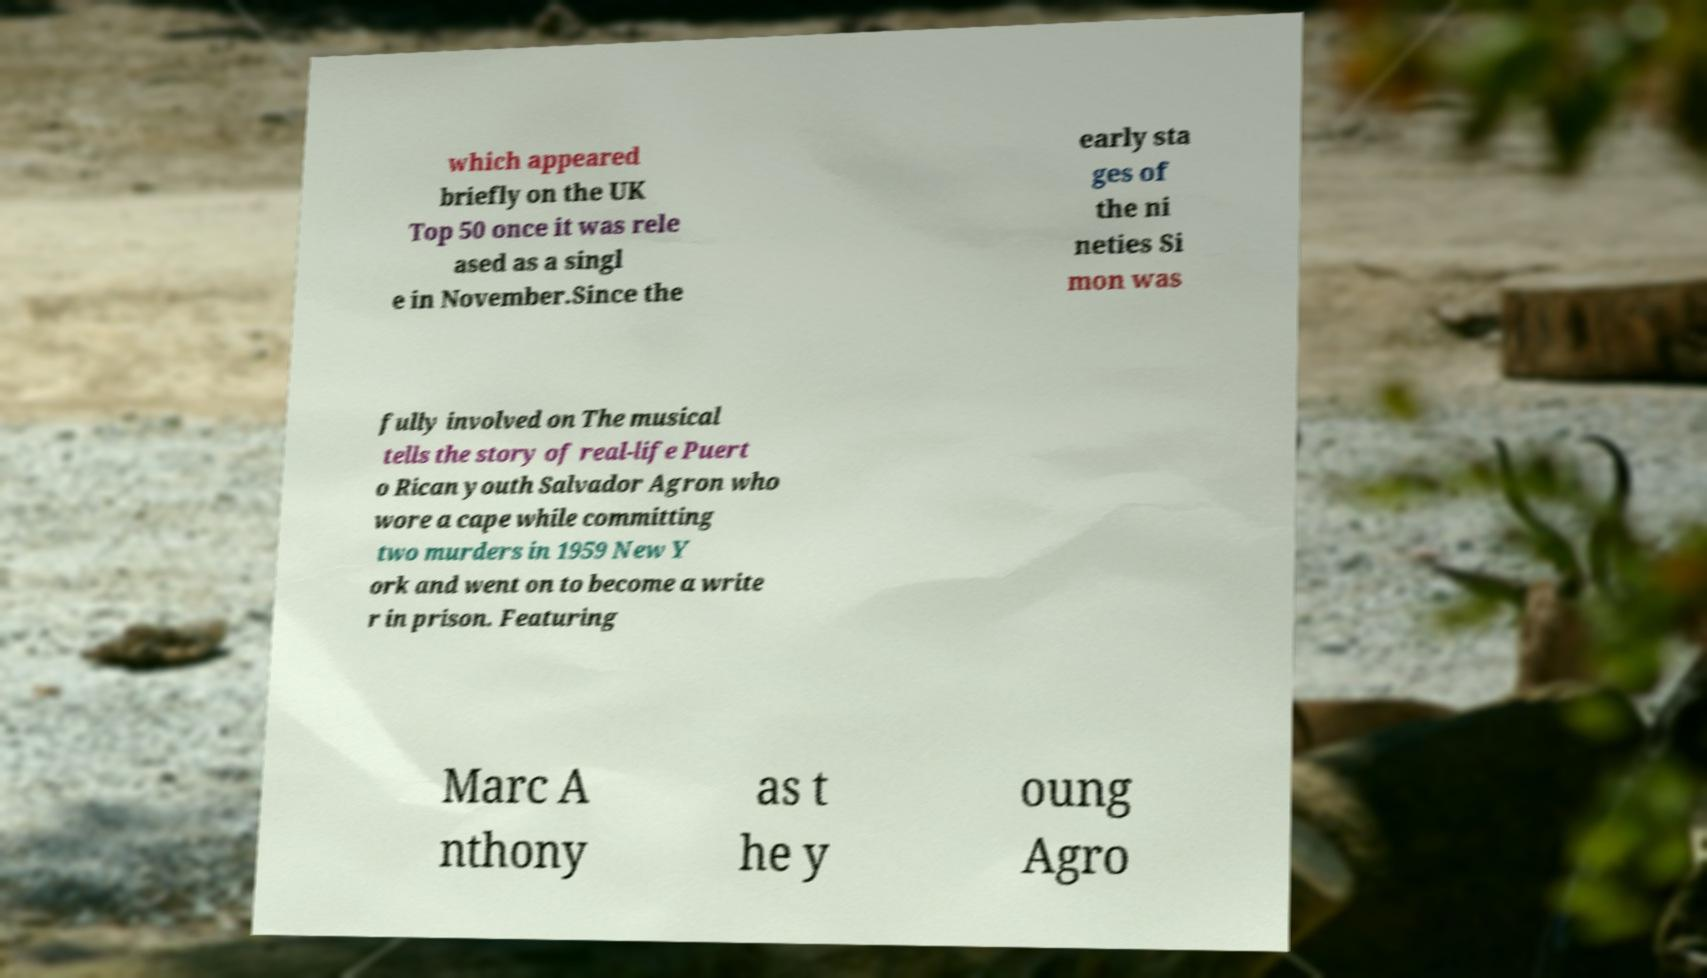Could you assist in decoding the text presented in this image and type it out clearly? which appeared briefly on the UK Top 50 once it was rele ased as a singl e in November.Since the early sta ges of the ni neties Si mon was fully involved on The musical tells the story of real-life Puert o Rican youth Salvador Agron who wore a cape while committing two murders in 1959 New Y ork and went on to become a write r in prison. Featuring Marc A nthony as t he y oung Agro 